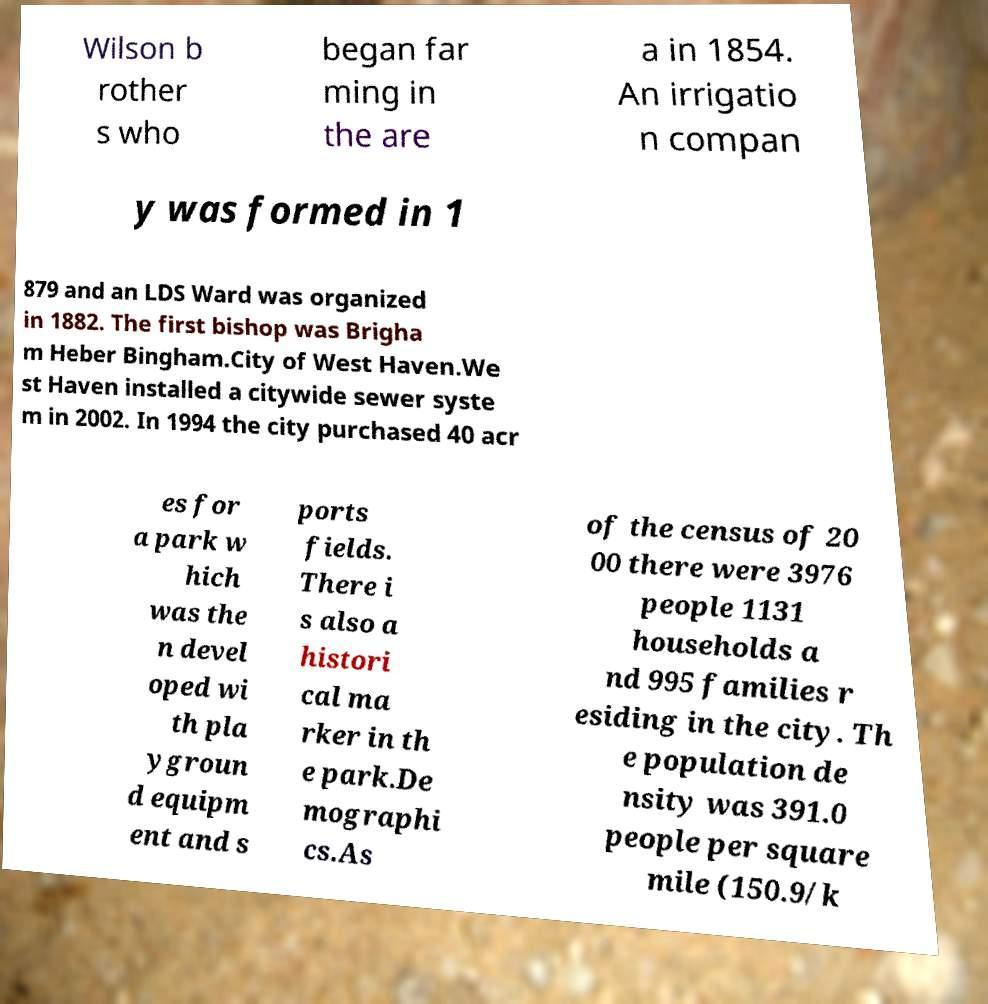Please identify and transcribe the text found in this image. Wilson b rother s who began far ming in the are a in 1854. An irrigatio n compan y was formed in 1 879 and an LDS Ward was organized in 1882. The first bishop was Brigha m Heber Bingham.City of West Haven.We st Haven installed a citywide sewer syste m in 2002. In 1994 the city purchased 40 acr es for a park w hich was the n devel oped wi th pla ygroun d equipm ent and s ports fields. There i s also a histori cal ma rker in th e park.De mographi cs.As of the census of 20 00 there were 3976 people 1131 households a nd 995 families r esiding in the city. Th e population de nsity was 391.0 people per square mile (150.9/k 